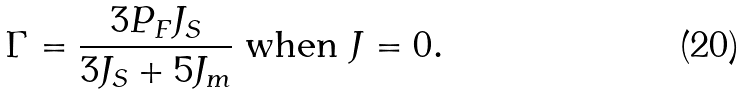<formula> <loc_0><loc_0><loc_500><loc_500>\Gamma = \frac { 3 P _ { F } J _ { S } } { 3 J _ { S } + 5 J _ { m } } \text { when } J = 0 .</formula> 